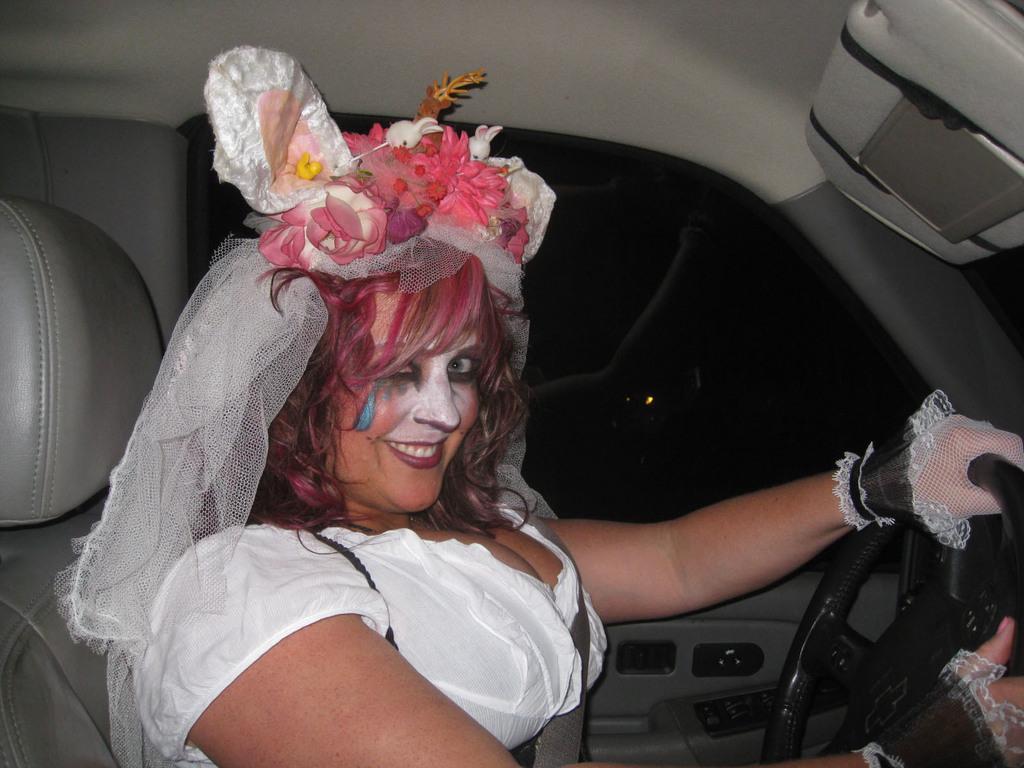How would you summarize this image in a sentence or two? Here in this picture we can see a woman sitting in a car and we can see she is wearing a costume and face paint and smiling and we can see gloves on her hand, that are present on the steering and beside them we can see a glass window present. 